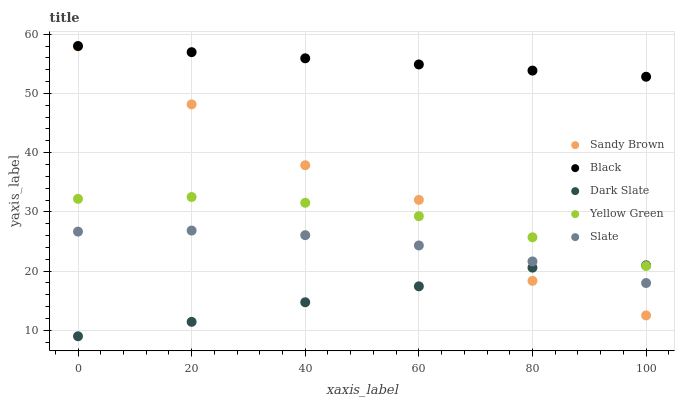Does Dark Slate have the minimum area under the curve?
Answer yes or no. Yes. Does Black have the maximum area under the curve?
Answer yes or no. Yes. Does Slate have the minimum area under the curve?
Answer yes or no. No. Does Slate have the maximum area under the curve?
Answer yes or no. No. Is Black the smoothest?
Answer yes or no. Yes. Is Sandy Brown the roughest?
Answer yes or no. Yes. Is Slate the smoothest?
Answer yes or no. No. Is Slate the roughest?
Answer yes or no. No. Does Dark Slate have the lowest value?
Answer yes or no. Yes. Does Slate have the lowest value?
Answer yes or no. No. Does Black have the highest value?
Answer yes or no. Yes. Does Slate have the highest value?
Answer yes or no. No. Is Dark Slate less than Black?
Answer yes or no. Yes. Is Black greater than Slate?
Answer yes or no. Yes. Does Sandy Brown intersect Slate?
Answer yes or no. Yes. Is Sandy Brown less than Slate?
Answer yes or no. No. Is Sandy Brown greater than Slate?
Answer yes or no. No. Does Dark Slate intersect Black?
Answer yes or no. No. 